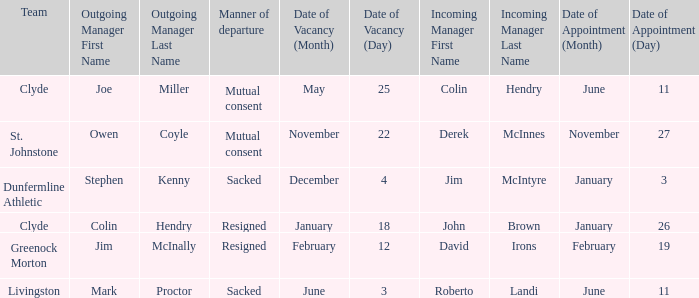Tell me the outgoing manager for livingston Mark Proctor. 